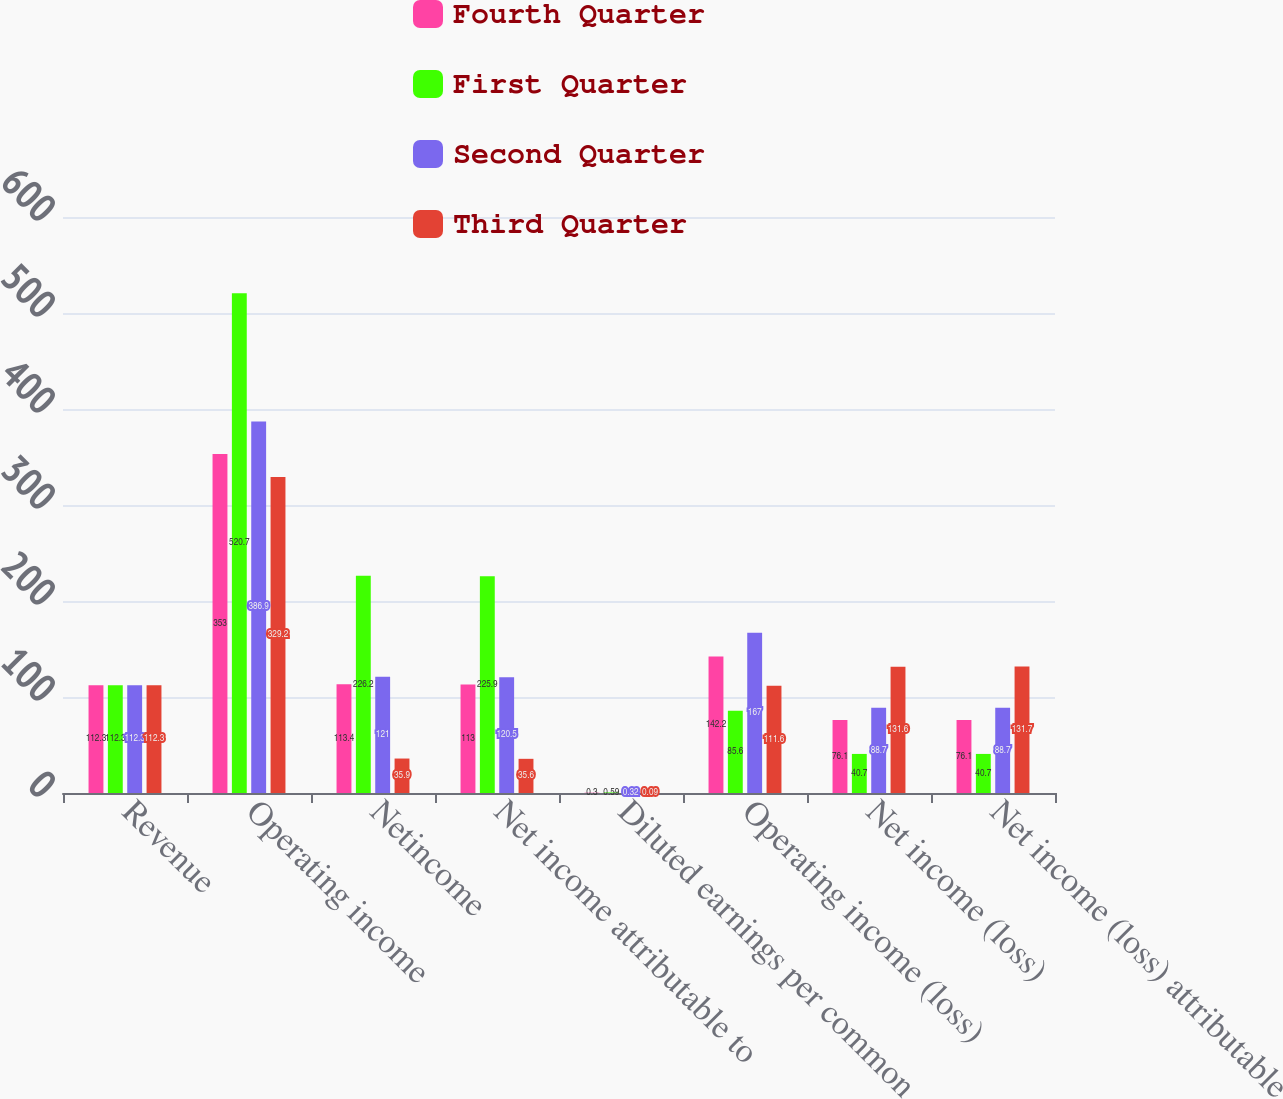Convert chart to OTSL. <chart><loc_0><loc_0><loc_500><loc_500><stacked_bar_chart><ecel><fcel>Revenue<fcel>Operating income<fcel>Netincome<fcel>Net income attributable to<fcel>Diluted earnings per common<fcel>Operating income (loss)<fcel>Net income (loss)<fcel>Net income (loss) attributable<nl><fcel>Fourth Quarter<fcel>112.3<fcel>353<fcel>113.4<fcel>113<fcel>0.3<fcel>142.2<fcel>76.1<fcel>76.1<nl><fcel>First Quarter<fcel>112.3<fcel>520.7<fcel>226.2<fcel>225.9<fcel>0.59<fcel>85.6<fcel>40.7<fcel>40.7<nl><fcel>Second Quarter<fcel>112.3<fcel>386.9<fcel>121<fcel>120.5<fcel>0.32<fcel>167<fcel>88.7<fcel>88.7<nl><fcel>Third Quarter<fcel>112.3<fcel>329.2<fcel>35.9<fcel>35.6<fcel>0.09<fcel>111.6<fcel>131.6<fcel>131.7<nl></chart> 